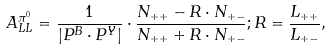Convert formula to latex. <formula><loc_0><loc_0><loc_500><loc_500>A _ { L L } ^ { \pi ^ { 0 } } = \frac { 1 } { | P ^ { B } \cdot P ^ { Y } | } \cdot \frac { N _ { + + } - R \cdot N _ { + - } } { N _ { + + } + R \cdot N _ { + - } } ; R = \frac { L _ { + + } } { L _ { + - } } ,</formula> 